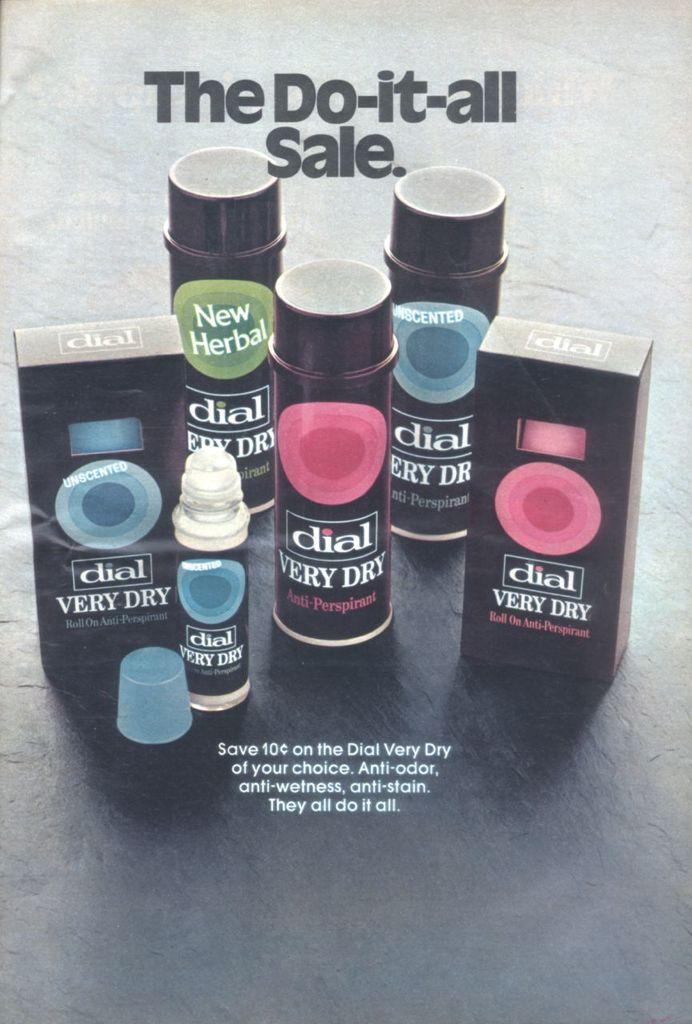Provide a one-sentence caption for the provided image. black bottles and boxes of dial very dry are on sale. 